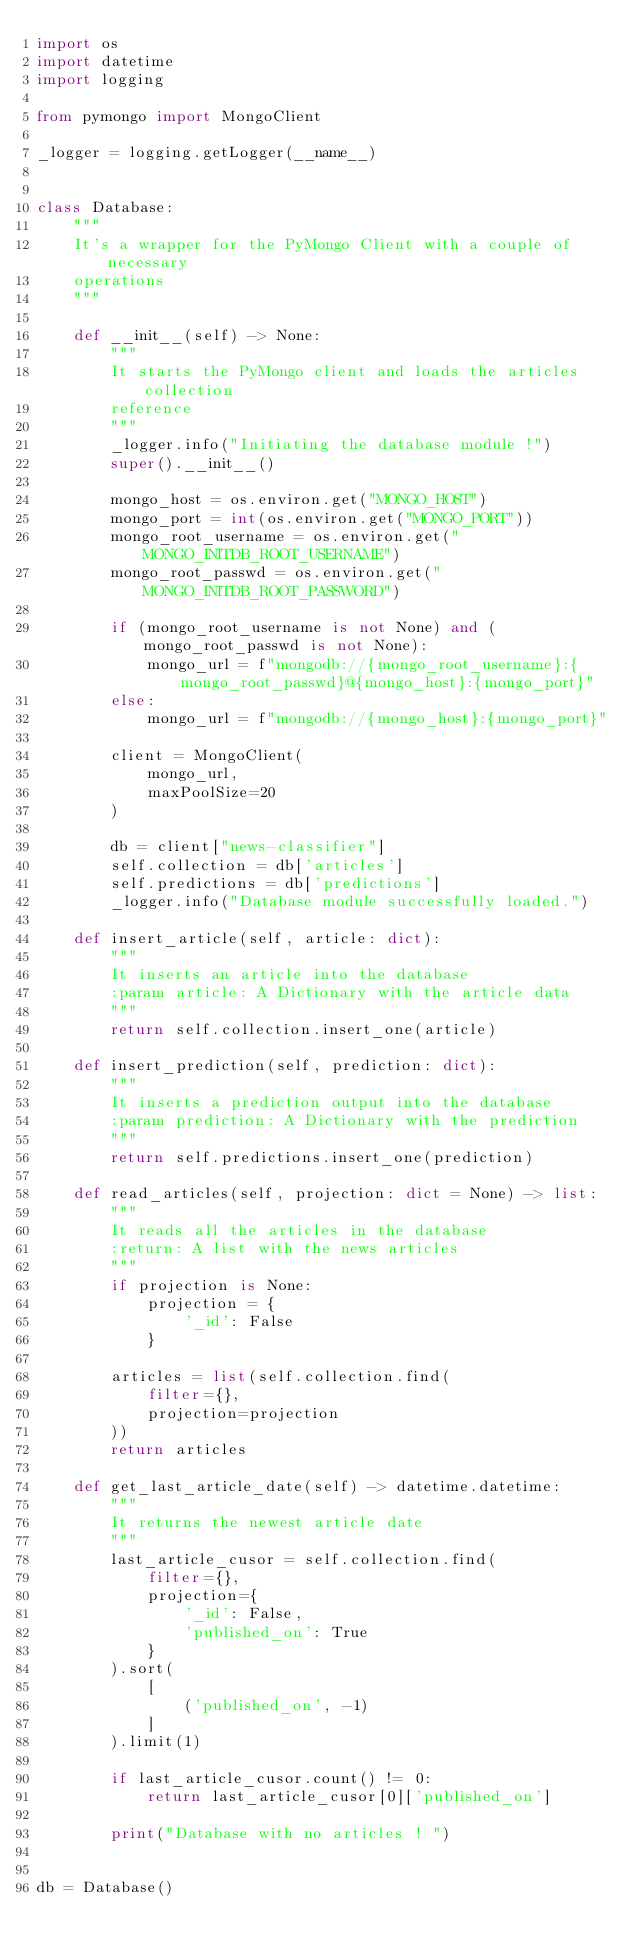Convert code to text. <code><loc_0><loc_0><loc_500><loc_500><_Python_>import os
import datetime
import logging

from pymongo import MongoClient

_logger = logging.getLogger(__name__)


class Database:
    """
    It's a wrapper for the PyMongo Client with a couple of necessary
    operations
    """

    def __init__(self) -> None:
        """
        It starts the PyMongo client and loads the articles collection
        reference
        """
        _logger.info("Initiating the database module !")
        super().__init__()

        mongo_host = os.environ.get("MONGO_HOST")
        mongo_port = int(os.environ.get("MONGO_PORT"))
        mongo_root_username = os.environ.get("MONGO_INITDB_ROOT_USERNAME")
        mongo_root_passwd = os.environ.get("MONGO_INITDB_ROOT_PASSWORD")

        if (mongo_root_username is not None) and (mongo_root_passwd is not None):
            mongo_url = f"mongodb://{mongo_root_username}:{mongo_root_passwd}@{mongo_host}:{mongo_port}"
        else:
            mongo_url = f"mongodb://{mongo_host}:{mongo_port}"

        client = MongoClient(
            mongo_url,
            maxPoolSize=20
        )

        db = client["news-classifier"]
        self.collection = db['articles']
        self.predictions = db['predictions']
        _logger.info("Database module successfully loaded.")

    def insert_article(self, article: dict):
        """
        It inserts an article into the database
        :param article: A Dictionary with the article data
        """
        return self.collection.insert_one(article)

    def insert_prediction(self, prediction: dict):
        """
        It inserts a prediction output into the database
        :param prediction: A Dictionary with the prediction
        """
        return self.predictions.insert_one(prediction)

    def read_articles(self, projection: dict = None) -> list:
        """
        It reads all the articles in the database
        :return: A list with the news articles
        """
        if projection is None:
            projection = {
                '_id': False
            }

        articles = list(self.collection.find(
            filter={},
            projection=projection
        ))
        return articles

    def get_last_article_date(self) -> datetime.datetime:
        """
        It returns the newest article date
        """
        last_article_cusor = self.collection.find(
            filter={},
            projection={
                '_id': False,
                'published_on': True
            }
        ).sort(
            [
                ('published_on', -1)
            ]
        ).limit(1)

        if last_article_cusor.count() != 0:
            return last_article_cusor[0]['published_on']

        print("Database with no articles ! ")


db = Database()
</code> 